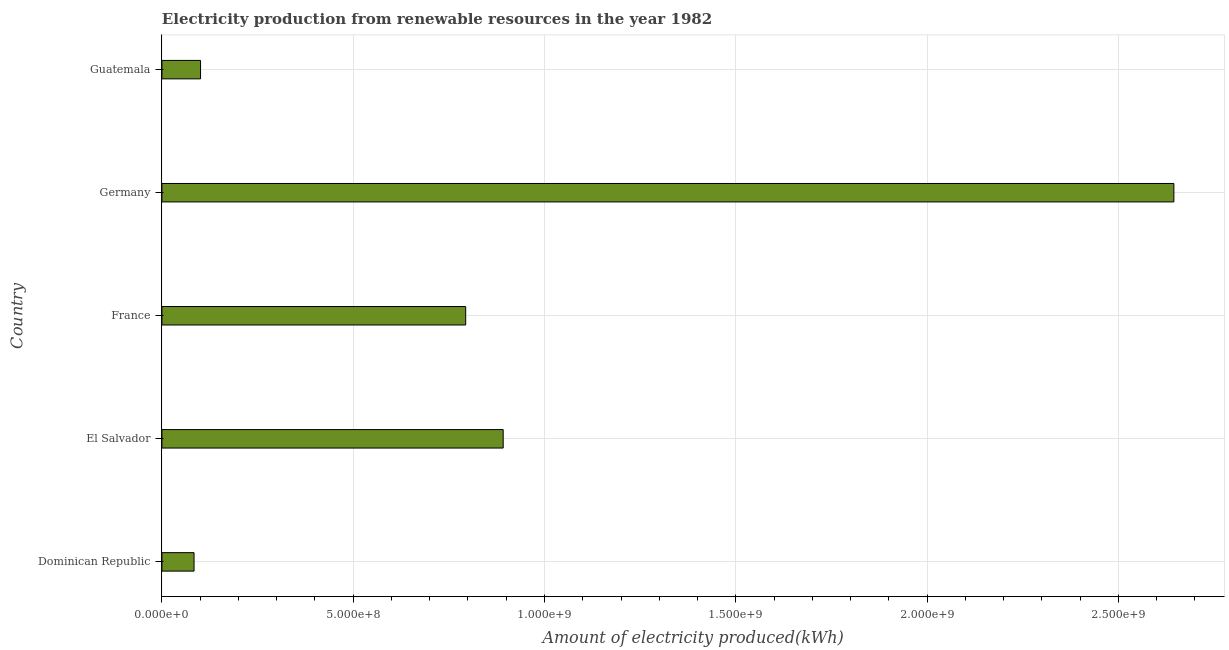What is the title of the graph?
Your response must be concise. Electricity production from renewable resources in the year 1982. What is the label or title of the X-axis?
Keep it short and to the point. Amount of electricity produced(kWh). What is the label or title of the Y-axis?
Make the answer very short. Country. What is the amount of electricity produced in France?
Offer a very short reply. 7.94e+08. Across all countries, what is the maximum amount of electricity produced?
Ensure brevity in your answer.  2.64e+09. Across all countries, what is the minimum amount of electricity produced?
Make the answer very short. 8.40e+07. In which country was the amount of electricity produced minimum?
Give a very brief answer. Dominican Republic. What is the sum of the amount of electricity produced?
Keep it short and to the point. 4.52e+09. What is the difference between the amount of electricity produced in El Salvador and Guatemala?
Offer a terse response. 7.91e+08. What is the average amount of electricity produced per country?
Your answer should be very brief. 9.03e+08. What is the median amount of electricity produced?
Keep it short and to the point. 7.94e+08. What is the ratio of the amount of electricity produced in Dominican Republic to that in El Salvador?
Give a very brief answer. 0.09. Is the amount of electricity produced in Dominican Republic less than that in El Salvador?
Ensure brevity in your answer.  Yes. What is the difference between the highest and the second highest amount of electricity produced?
Offer a terse response. 1.75e+09. What is the difference between the highest and the lowest amount of electricity produced?
Offer a terse response. 2.56e+09. In how many countries, is the amount of electricity produced greater than the average amount of electricity produced taken over all countries?
Offer a very short reply. 1. Are all the bars in the graph horizontal?
Your response must be concise. Yes. How many countries are there in the graph?
Your answer should be compact. 5. What is the difference between two consecutive major ticks on the X-axis?
Keep it short and to the point. 5.00e+08. Are the values on the major ticks of X-axis written in scientific E-notation?
Your response must be concise. Yes. What is the Amount of electricity produced(kWh) in Dominican Republic?
Make the answer very short. 8.40e+07. What is the Amount of electricity produced(kWh) in El Salvador?
Offer a terse response. 8.92e+08. What is the Amount of electricity produced(kWh) in France?
Provide a succinct answer. 7.94e+08. What is the Amount of electricity produced(kWh) of Germany?
Give a very brief answer. 2.64e+09. What is the Amount of electricity produced(kWh) in Guatemala?
Offer a very short reply. 1.01e+08. What is the difference between the Amount of electricity produced(kWh) in Dominican Republic and El Salvador?
Offer a very short reply. -8.08e+08. What is the difference between the Amount of electricity produced(kWh) in Dominican Republic and France?
Provide a succinct answer. -7.10e+08. What is the difference between the Amount of electricity produced(kWh) in Dominican Republic and Germany?
Make the answer very short. -2.56e+09. What is the difference between the Amount of electricity produced(kWh) in Dominican Republic and Guatemala?
Keep it short and to the point. -1.70e+07. What is the difference between the Amount of electricity produced(kWh) in El Salvador and France?
Offer a terse response. 9.80e+07. What is the difference between the Amount of electricity produced(kWh) in El Salvador and Germany?
Your response must be concise. -1.75e+09. What is the difference between the Amount of electricity produced(kWh) in El Salvador and Guatemala?
Make the answer very short. 7.91e+08. What is the difference between the Amount of electricity produced(kWh) in France and Germany?
Make the answer very short. -1.85e+09. What is the difference between the Amount of electricity produced(kWh) in France and Guatemala?
Ensure brevity in your answer.  6.93e+08. What is the difference between the Amount of electricity produced(kWh) in Germany and Guatemala?
Your answer should be compact. 2.54e+09. What is the ratio of the Amount of electricity produced(kWh) in Dominican Republic to that in El Salvador?
Your answer should be very brief. 0.09. What is the ratio of the Amount of electricity produced(kWh) in Dominican Republic to that in France?
Offer a very short reply. 0.11. What is the ratio of the Amount of electricity produced(kWh) in Dominican Republic to that in Germany?
Make the answer very short. 0.03. What is the ratio of the Amount of electricity produced(kWh) in Dominican Republic to that in Guatemala?
Your response must be concise. 0.83. What is the ratio of the Amount of electricity produced(kWh) in El Salvador to that in France?
Offer a very short reply. 1.12. What is the ratio of the Amount of electricity produced(kWh) in El Salvador to that in Germany?
Give a very brief answer. 0.34. What is the ratio of the Amount of electricity produced(kWh) in El Salvador to that in Guatemala?
Offer a terse response. 8.83. What is the ratio of the Amount of electricity produced(kWh) in France to that in Germany?
Ensure brevity in your answer.  0.3. What is the ratio of the Amount of electricity produced(kWh) in France to that in Guatemala?
Offer a terse response. 7.86. What is the ratio of the Amount of electricity produced(kWh) in Germany to that in Guatemala?
Provide a succinct answer. 26.19. 